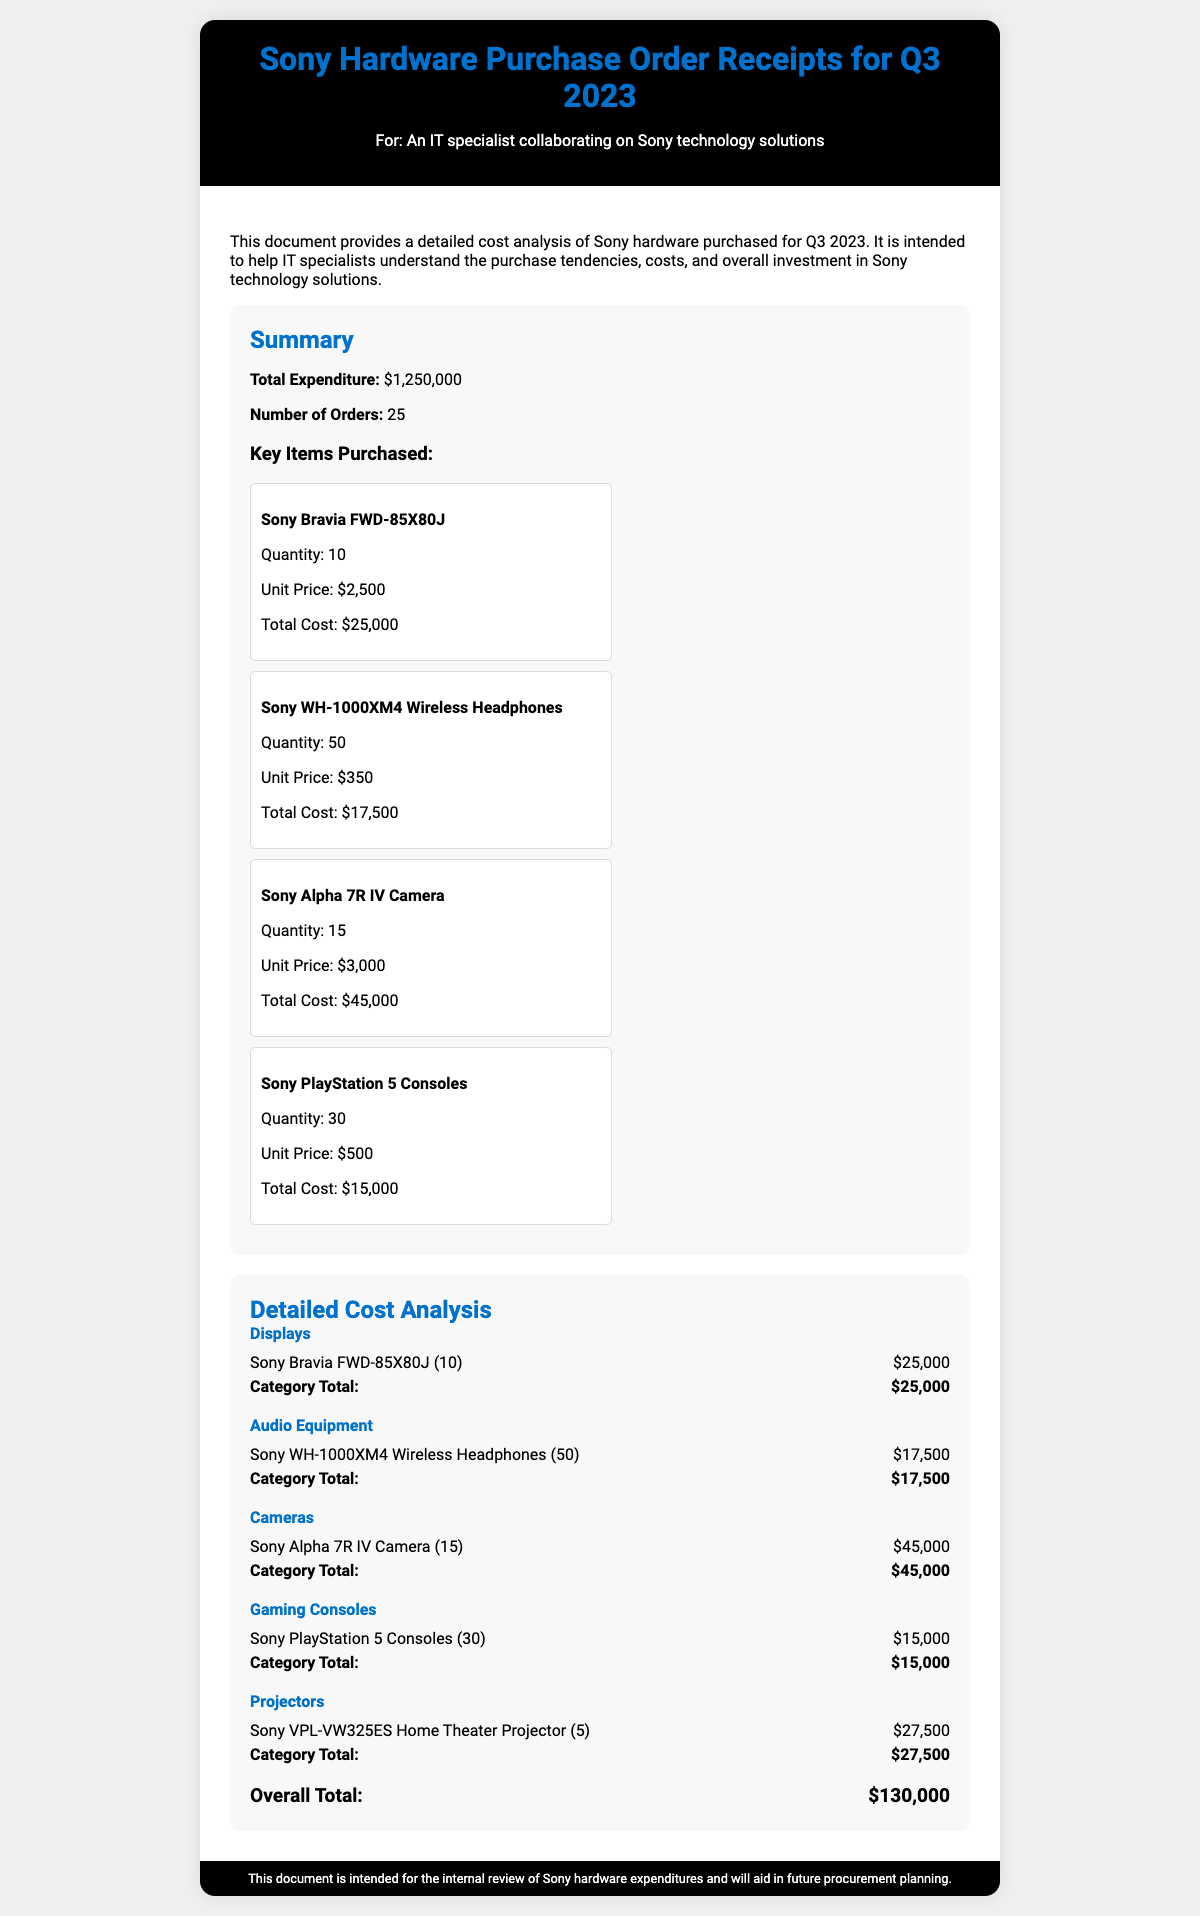what is the total expenditure? The total expenditure is provided in the summary section of the document, which states that the total expenditure is $1,250,000.
Answer: $1,250,000 how many orders were placed? The number of orders is listed in the summary section of the document, where it mentions 25 orders.
Answer: 25 what is the unit price of the Sony Alpha 7R IV Camera? The document specifies that the unit price for the Sony Alpha 7R IV Camera is $3,000.
Answer: $3,000 how many Sony WH-1000XM4 Wireless Headphones were purchased? According to the key items purchased section, 50 Sony WH-1000XM4 Wireless Headphones were acquired.
Answer: 50 what is the total cost of Sony PlayStation 5 Consoles? The key items purchased section states that the total cost of Sony PlayStation 5 Consoles is $15,000.
Answer: $15,000 which category had the highest expenditure? By analyzing the detailed cost analysis, the Cameras category had the highest total expenditure at $45,000.
Answer: Cameras what is the total cost of the Displays category? The total cost for the Displays category is specifically stated as $25,000 in the detailed cost analysis.
Answer: $25,000 how many Sony VPL-VW325ES Projectors were purchased? In the detailed cost analysis, it is noted that 5 Sony VPL-VW325ES Home Theater Projectors were purchased.
Answer: 5 what is the overall total expenditure mentioned in the detailed analysis? The overall total expenditure is summarized at the end of the detailed analysis section, which states $130,000.
Answer: $130,000 